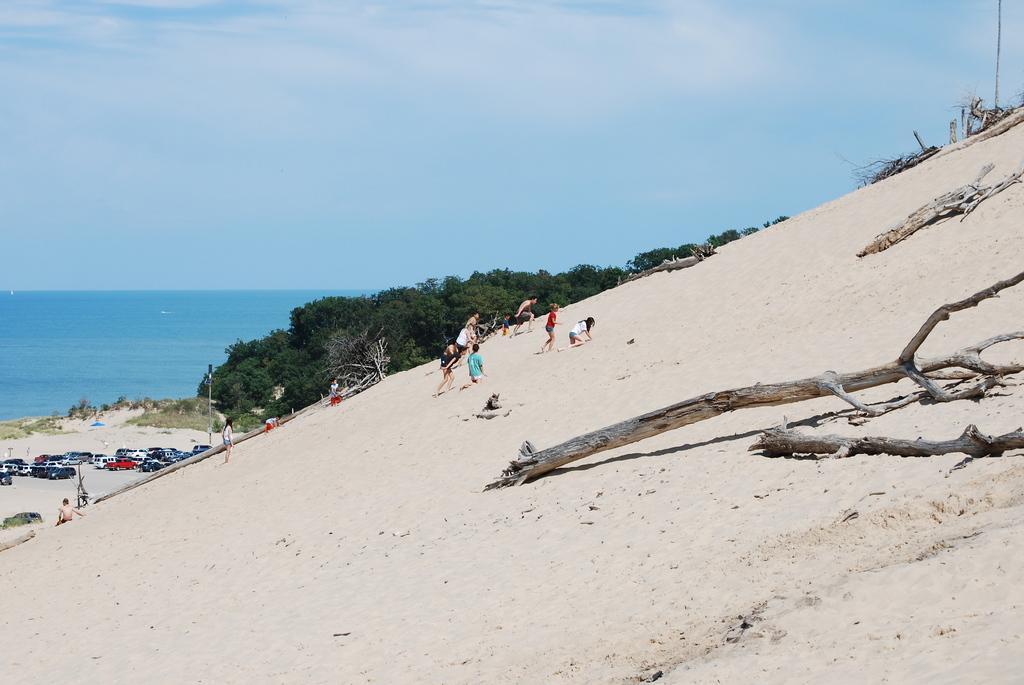Please provide a concise description of this image. In the image I can see some people, tree trunks on the sand floor and to the side there is a sea and some people, cars and some trees to the side. 